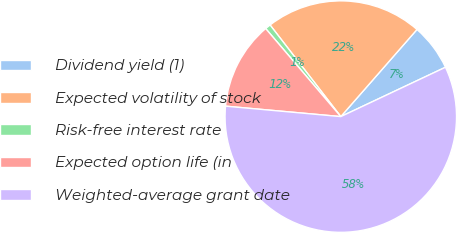Convert chart to OTSL. <chart><loc_0><loc_0><loc_500><loc_500><pie_chart><fcel>Dividend yield (1)<fcel>Expected volatility of stock<fcel>Risk-free interest rate<fcel>Expected option life (in<fcel>Weighted-average grant date<nl><fcel>6.55%<fcel>21.9%<fcel>0.78%<fcel>12.32%<fcel>58.45%<nl></chart> 